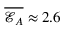Convert formula to latex. <formula><loc_0><loc_0><loc_500><loc_500>\overline { { \mathcal { E } _ { A } } } \approx 2 . 6</formula> 